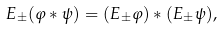Convert formula to latex. <formula><loc_0><loc_0><loc_500><loc_500>E _ { \pm } ( \varphi \ast \psi ) = ( E _ { \pm } \varphi ) \ast ( E _ { \pm } \psi ) ,</formula> 